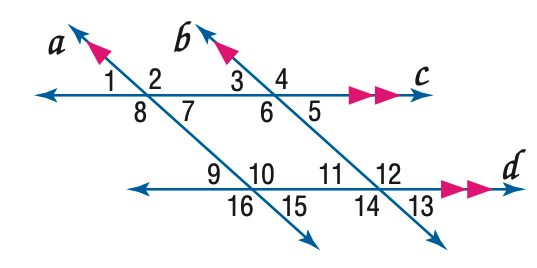Answer the mathemtical geometry problem and directly provide the correct option letter.
Question: In the figure, m \angle 3 = 43. Find the measure of \angle 2.
Choices: A: 43 B: 127 C: 137 D: 147 C 